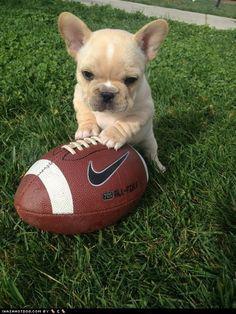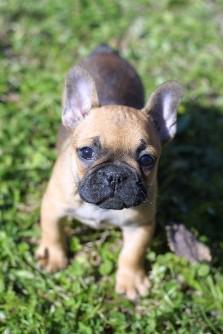The first image is the image on the left, the second image is the image on the right. Considering the images on both sides, is "The left image contains exactly two dogs." valid? Answer yes or no. No. The first image is the image on the left, the second image is the image on the right. Examine the images to the left and right. Is the description "In one image, a dog has its paw resting on top of a ball" accurate? Answer yes or no. Yes. 